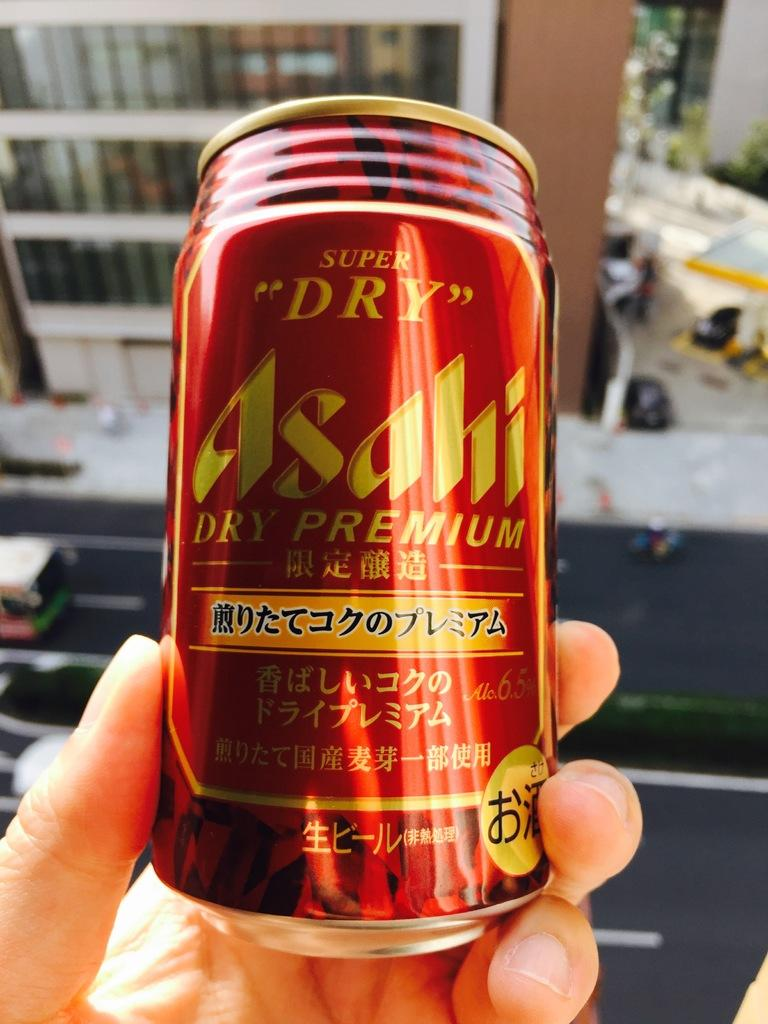<image>
Summarize the visual content of the image. A red can of Asahi is held by a hand. 